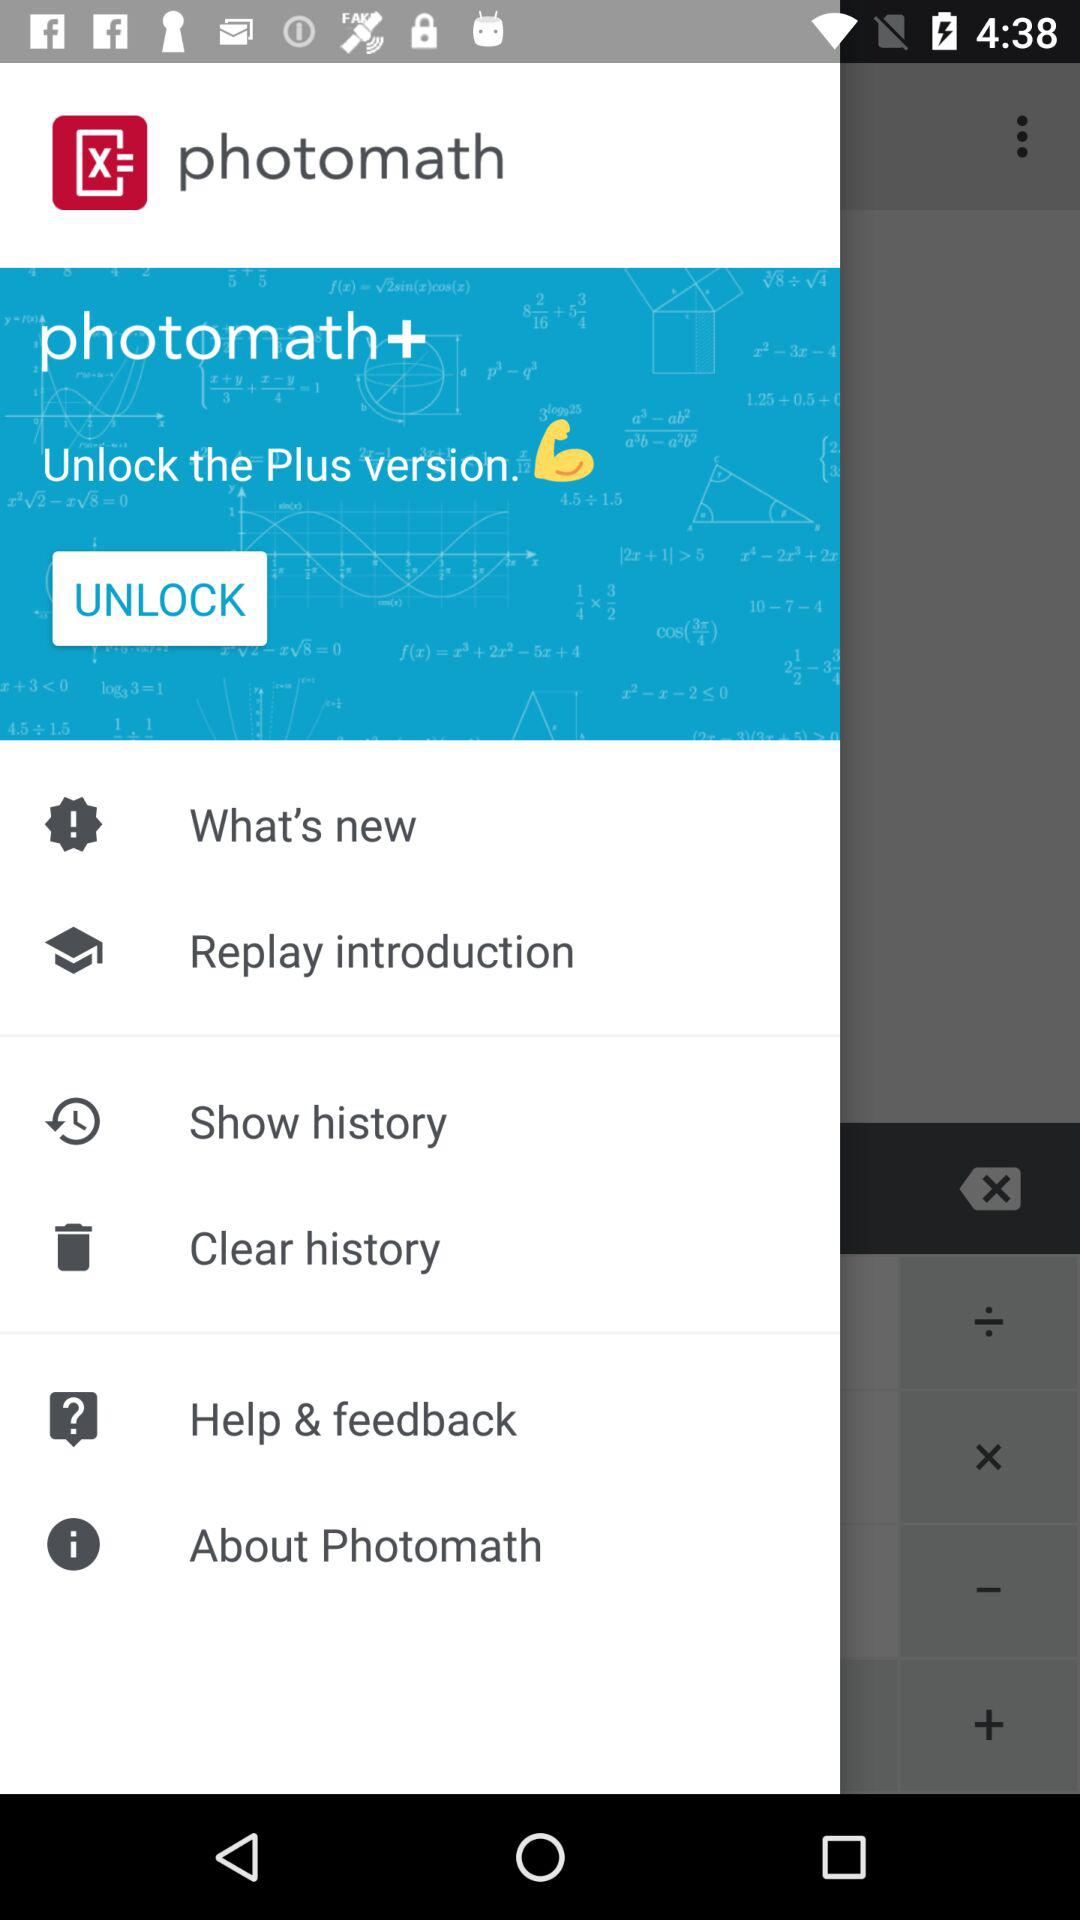Can we update the version?
When the provided information is insufficient, respond with <no answer>. <no answer> 